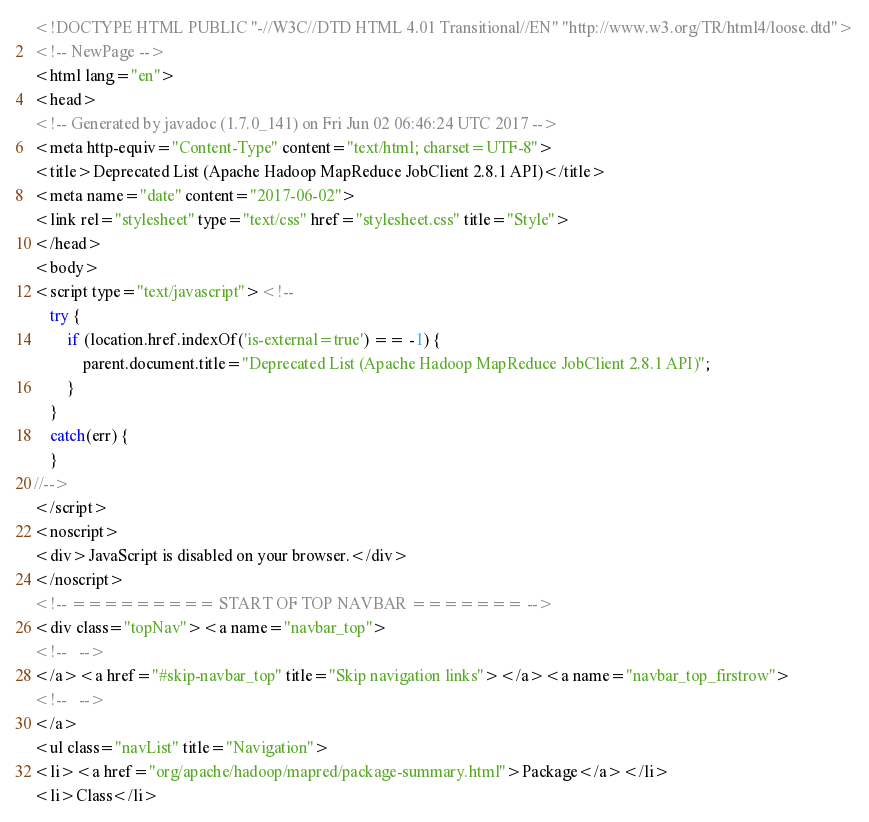Convert code to text. <code><loc_0><loc_0><loc_500><loc_500><_HTML_><!DOCTYPE HTML PUBLIC "-//W3C//DTD HTML 4.01 Transitional//EN" "http://www.w3.org/TR/html4/loose.dtd">
<!-- NewPage -->
<html lang="en">
<head>
<!-- Generated by javadoc (1.7.0_141) on Fri Jun 02 06:46:24 UTC 2017 -->
<meta http-equiv="Content-Type" content="text/html; charset=UTF-8">
<title>Deprecated List (Apache Hadoop MapReduce JobClient 2.8.1 API)</title>
<meta name="date" content="2017-06-02">
<link rel="stylesheet" type="text/css" href="stylesheet.css" title="Style">
</head>
<body>
<script type="text/javascript"><!--
    try {
        if (location.href.indexOf('is-external=true') == -1) {
            parent.document.title="Deprecated List (Apache Hadoop MapReduce JobClient 2.8.1 API)";
        }
    }
    catch(err) {
    }
//-->
</script>
<noscript>
<div>JavaScript is disabled on your browser.</div>
</noscript>
<!-- ========= START OF TOP NAVBAR ======= -->
<div class="topNav"><a name="navbar_top">
<!--   -->
</a><a href="#skip-navbar_top" title="Skip navigation links"></a><a name="navbar_top_firstrow">
<!--   -->
</a>
<ul class="navList" title="Navigation">
<li><a href="org/apache/hadoop/mapred/package-summary.html">Package</a></li>
<li>Class</li></code> 